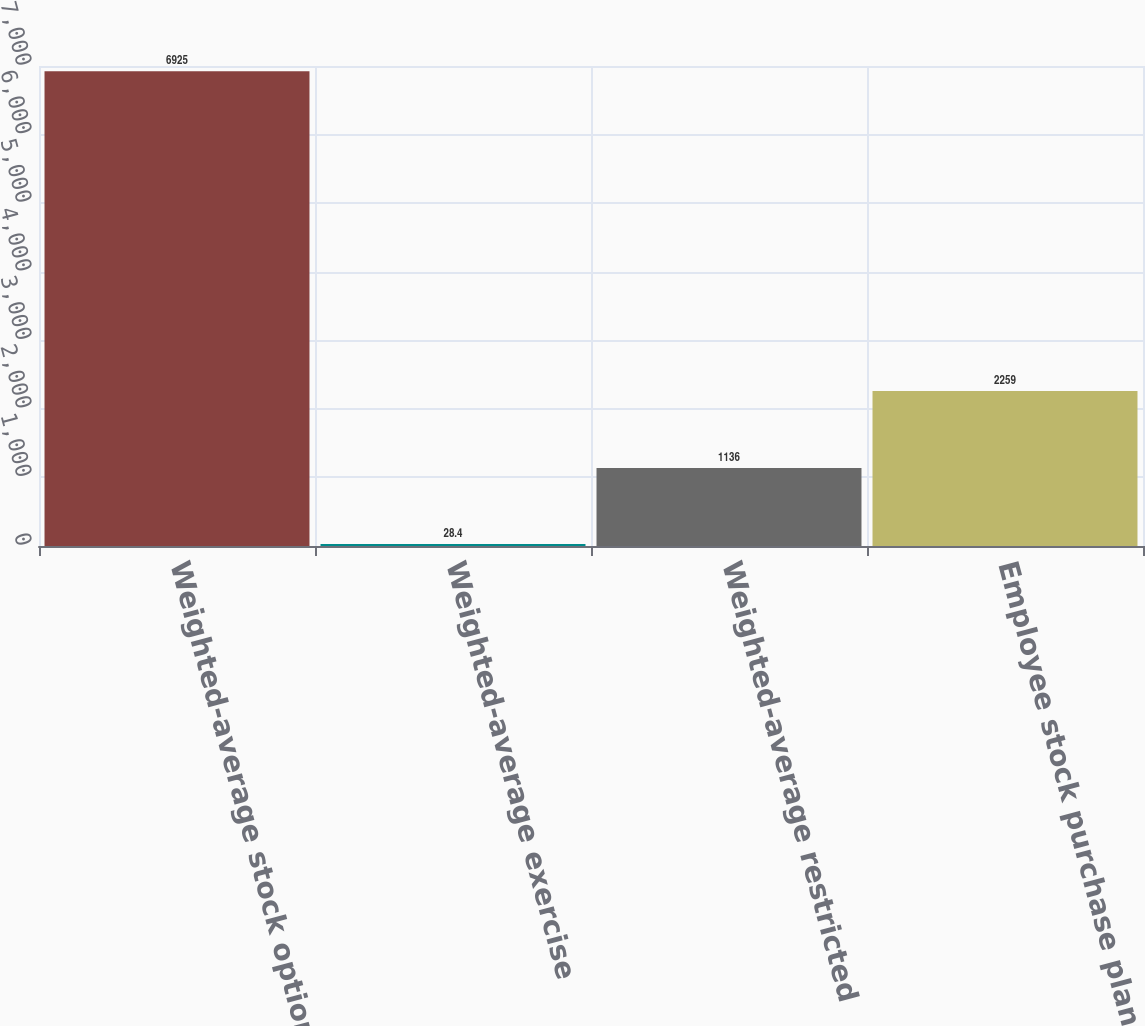Convert chart to OTSL. <chart><loc_0><loc_0><loc_500><loc_500><bar_chart><fcel>Weighted-average stock options<fcel>Weighted-average exercise<fcel>Weighted-average restricted<fcel>Employee stock purchase plans<nl><fcel>6925<fcel>28.4<fcel>1136<fcel>2259<nl></chart> 